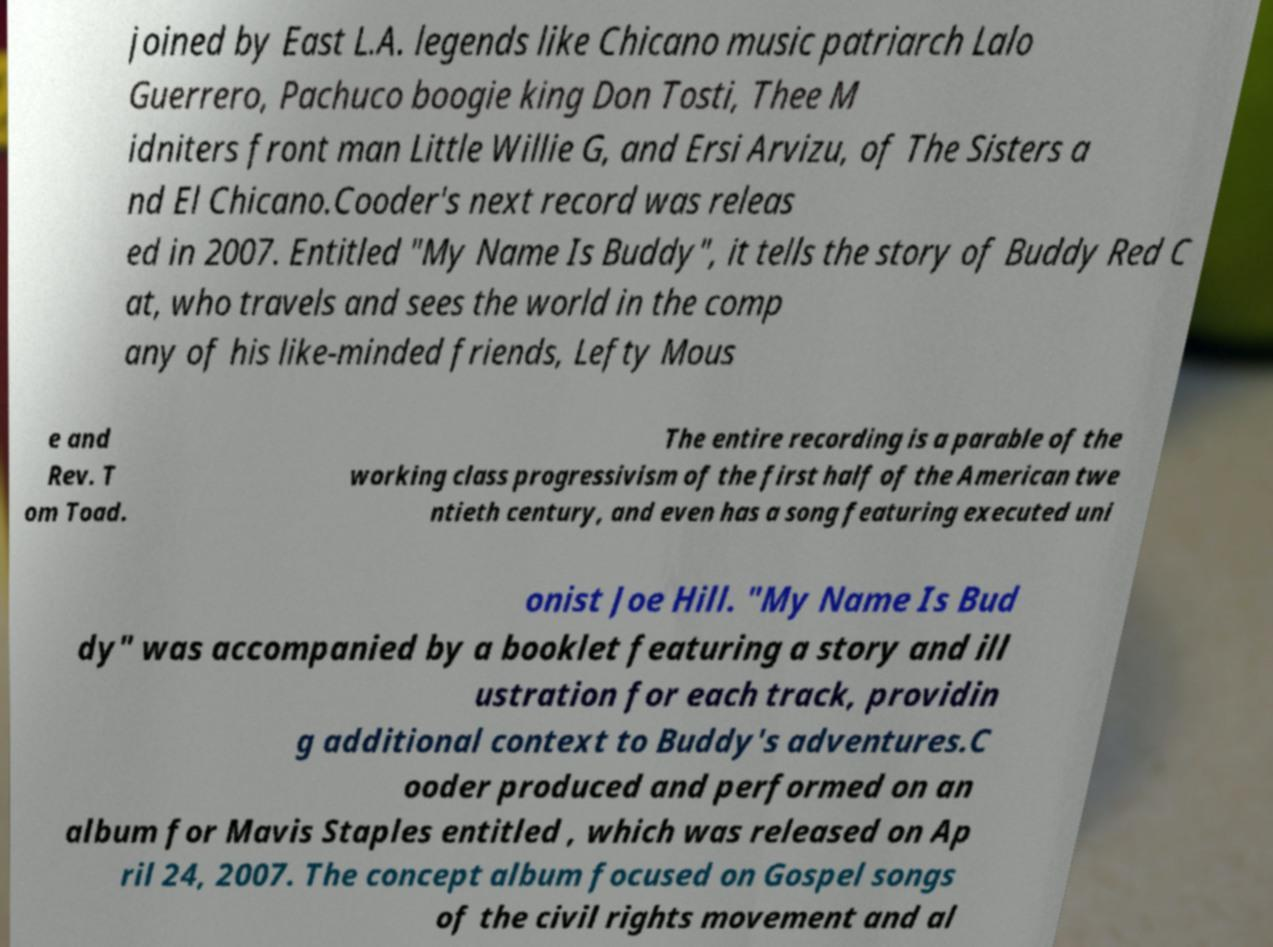Can you accurately transcribe the text from the provided image for me? joined by East L.A. legends like Chicano music patriarch Lalo Guerrero, Pachuco boogie king Don Tosti, Thee M idniters front man Little Willie G, and Ersi Arvizu, of The Sisters a nd El Chicano.Cooder's next record was releas ed in 2007. Entitled "My Name Is Buddy", it tells the story of Buddy Red C at, who travels and sees the world in the comp any of his like-minded friends, Lefty Mous e and Rev. T om Toad. The entire recording is a parable of the working class progressivism of the first half of the American twe ntieth century, and even has a song featuring executed uni onist Joe Hill. "My Name Is Bud dy" was accompanied by a booklet featuring a story and ill ustration for each track, providin g additional context to Buddy's adventures.C ooder produced and performed on an album for Mavis Staples entitled , which was released on Ap ril 24, 2007. The concept album focused on Gospel songs of the civil rights movement and al 